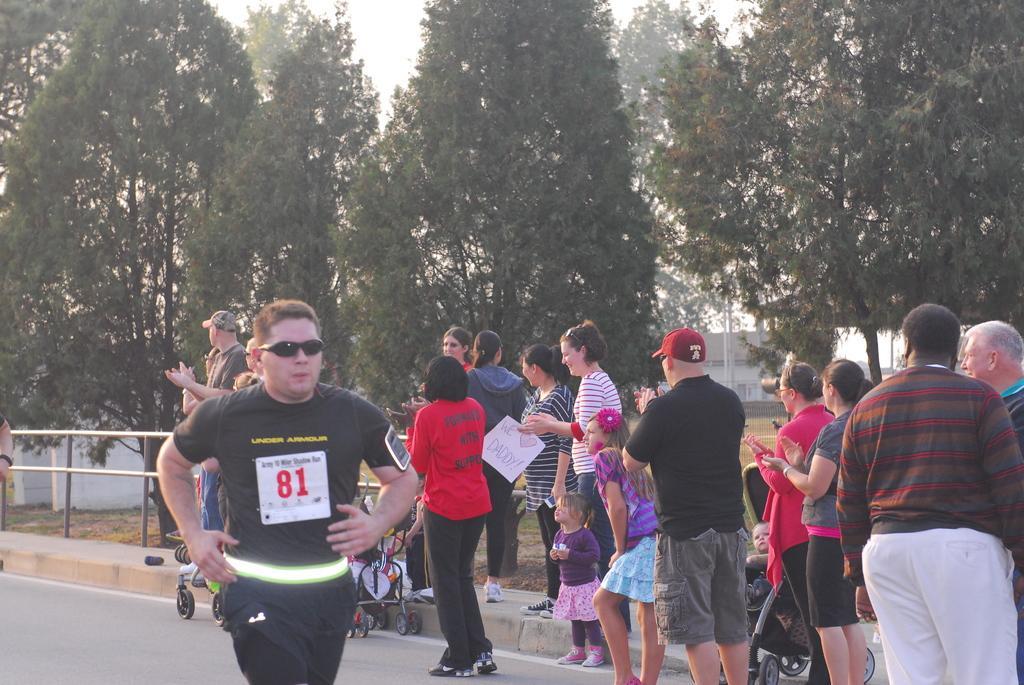Please provide a concise description of this image. In this image we can see many people. Few are wearing caps. Also there are strollers. And there is a road. Near to the road there is a railing. In the back there are trees. Also we can see a building. 